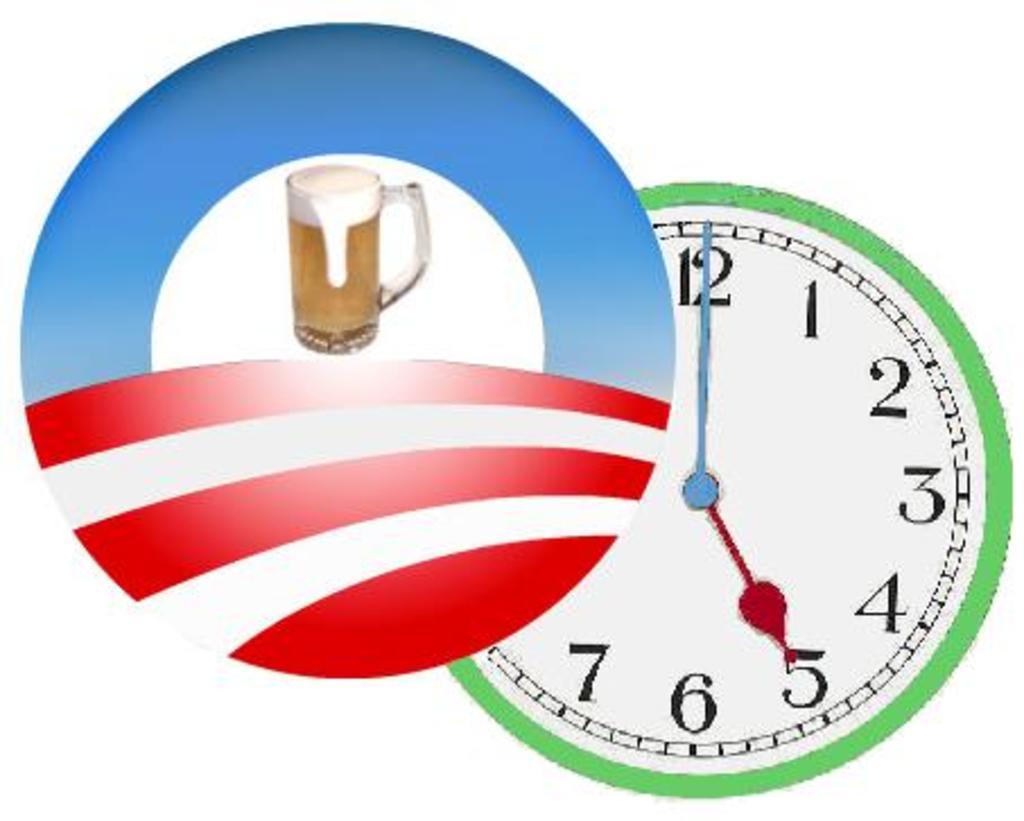What number is the small hand on?
Your answer should be compact. 5. 